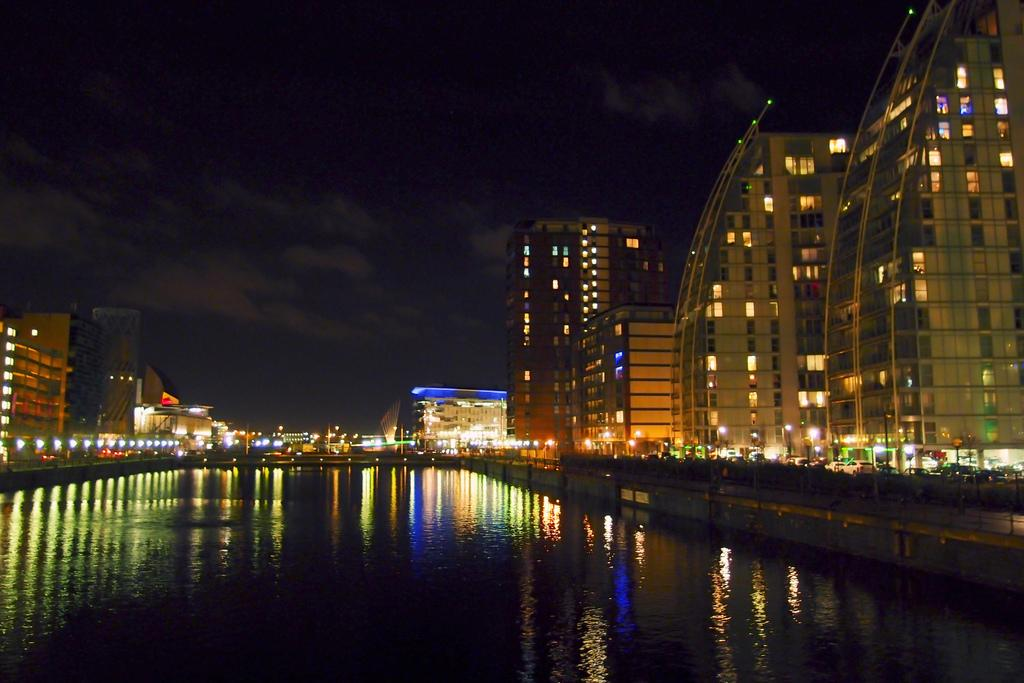What is the primary element visible in the image? There is water in the image. What can be seen on the left side of the image? There are buildings with colorful lights on the left side of the image. What can be seen on the right side of the image? There are buildings with colorful lights on the right side of the image. What type of arch can be seen in the morning in the image? There is no arch present in the image, and the time of day is not mentioned, so it cannot be determined if it is morning. 